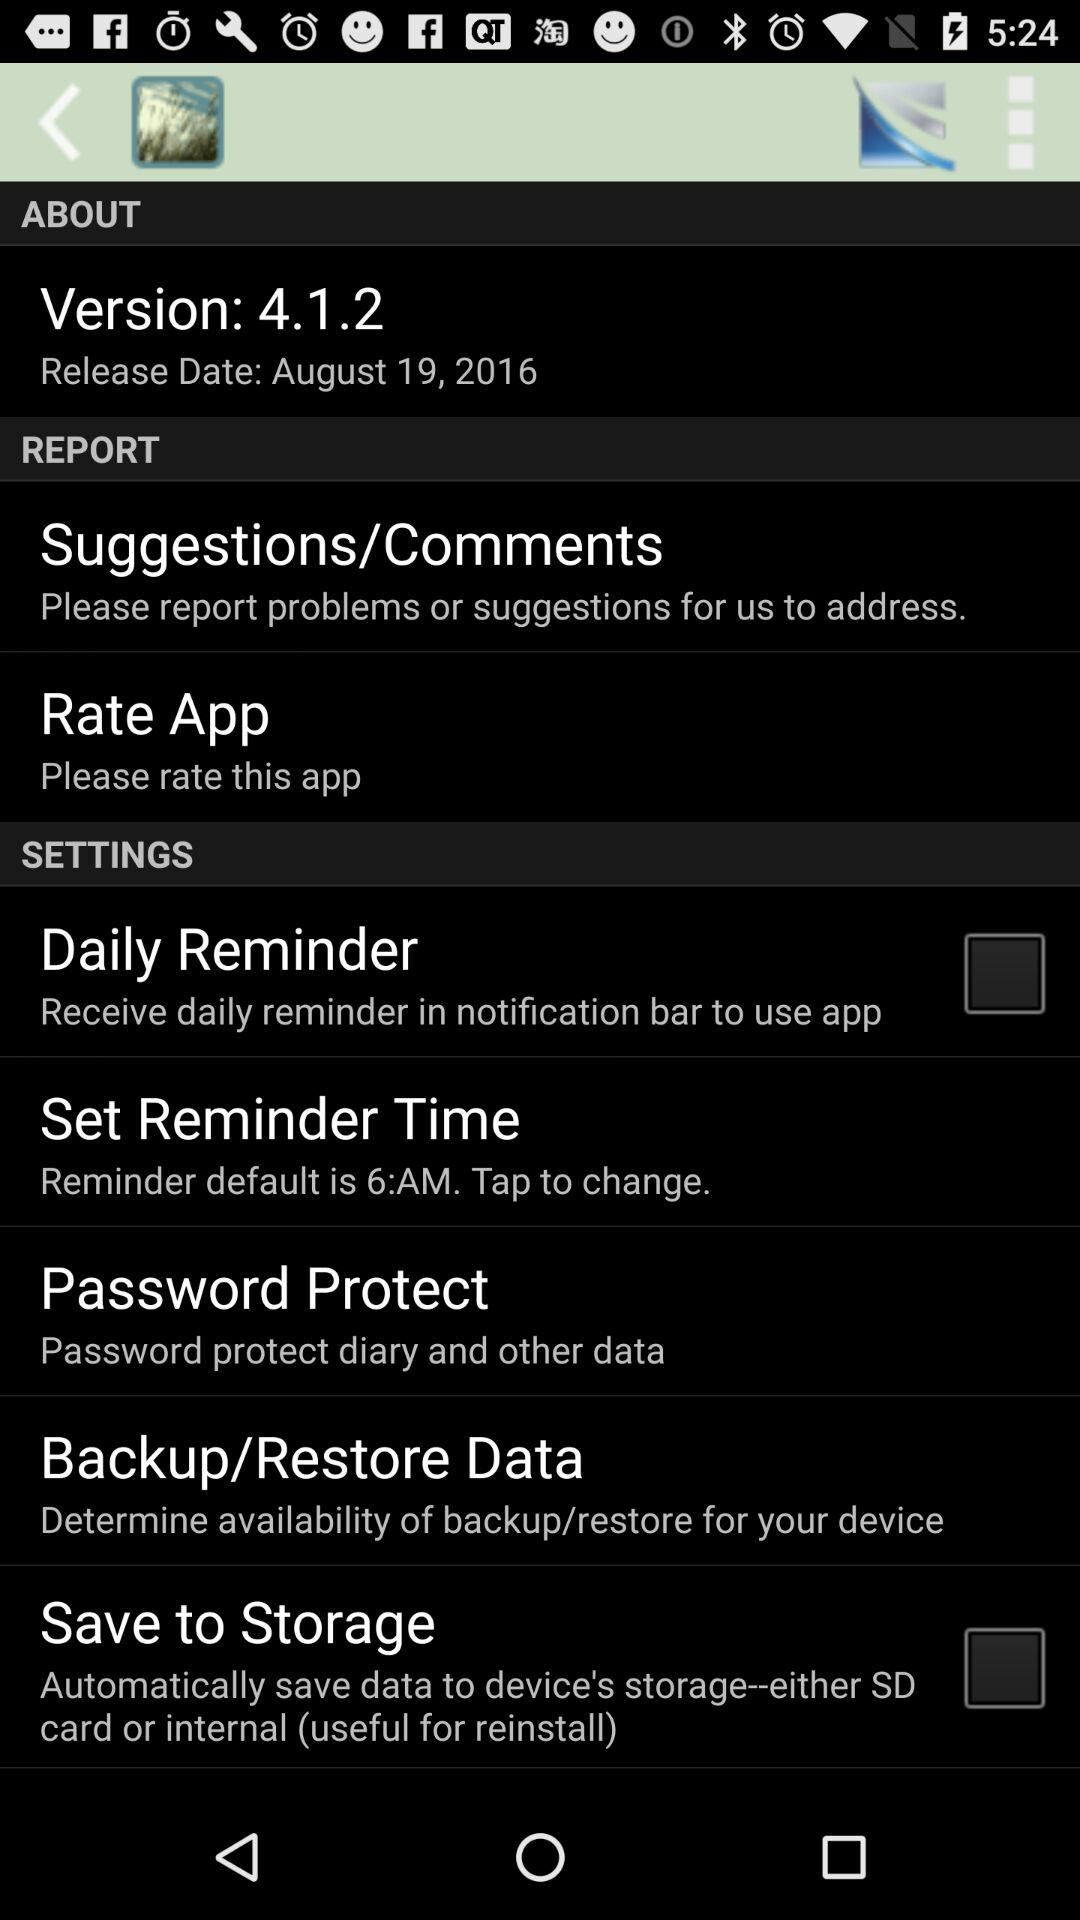What is the release date? The release date is August 19, 2016. 